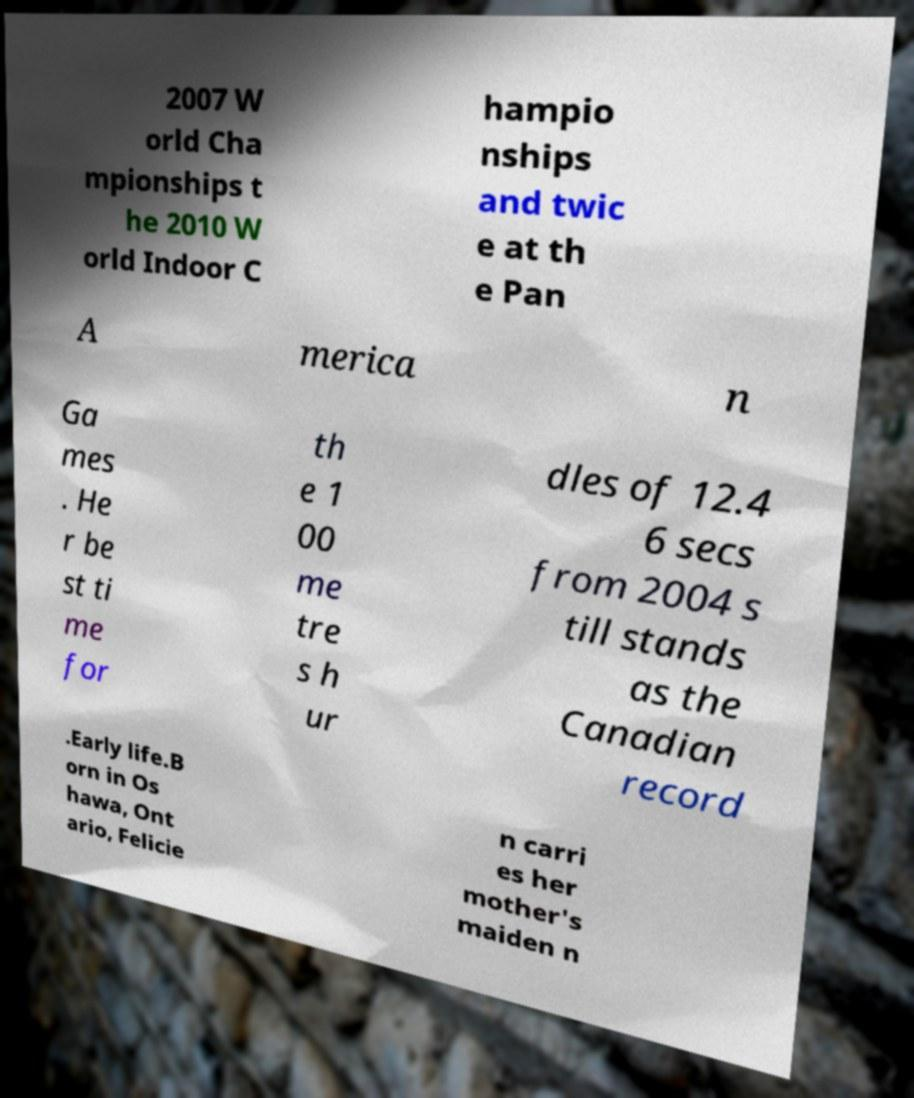For documentation purposes, I need the text within this image transcribed. Could you provide that? 2007 W orld Cha mpionships t he 2010 W orld Indoor C hampio nships and twic e at th e Pan A merica n Ga mes . He r be st ti me for th e 1 00 me tre s h ur dles of 12.4 6 secs from 2004 s till stands as the Canadian record .Early life.B orn in Os hawa, Ont ario, Felicie n carri es her mother's maiden n 